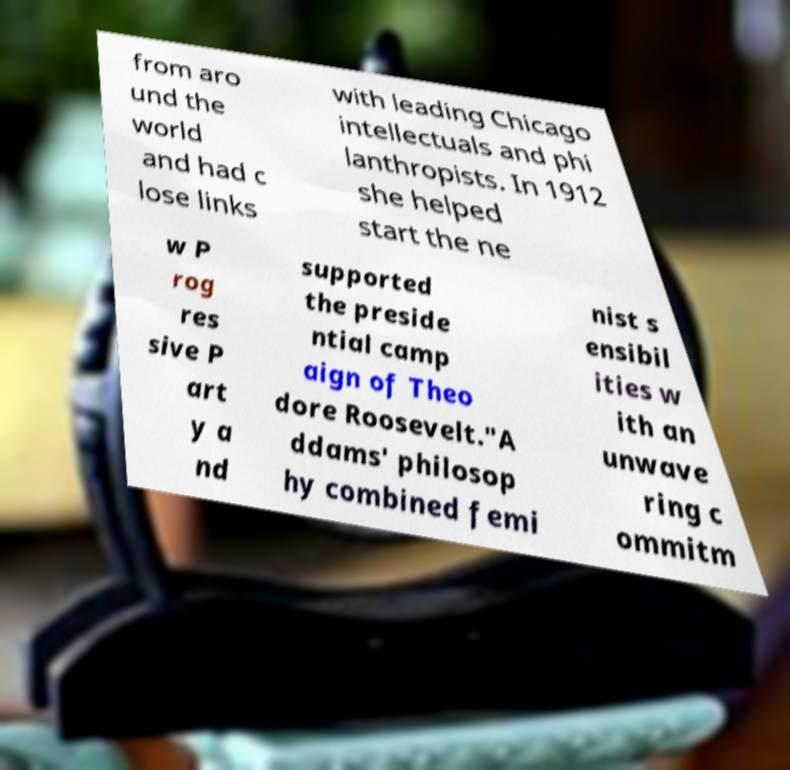Please read and relay the text visible in this image. What does it say? from aro und the world and had c lose links with leading Chicago intellectuals and phi lanthropists. In 1912 she helped start the ne w P rog res sive P art y a nd supported the preside ntial camp aign of Theo dore Roosevelt."A ddams' philosop hy combined femi nist s ensibil ities w ith an unwave ring c ommitm 